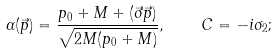<formula> <loc_0><loc_0><loc_500><loc_500>\alpha ( \vec { p } ) = \frac { p _ { 0 } + M + ( \vec { \sigma } \vec { p } ) } { \sqrt { 2 M ( p _ { 0 } + M ) } } , \quad C = - i \sigma _ { 2 } ;</formula> 